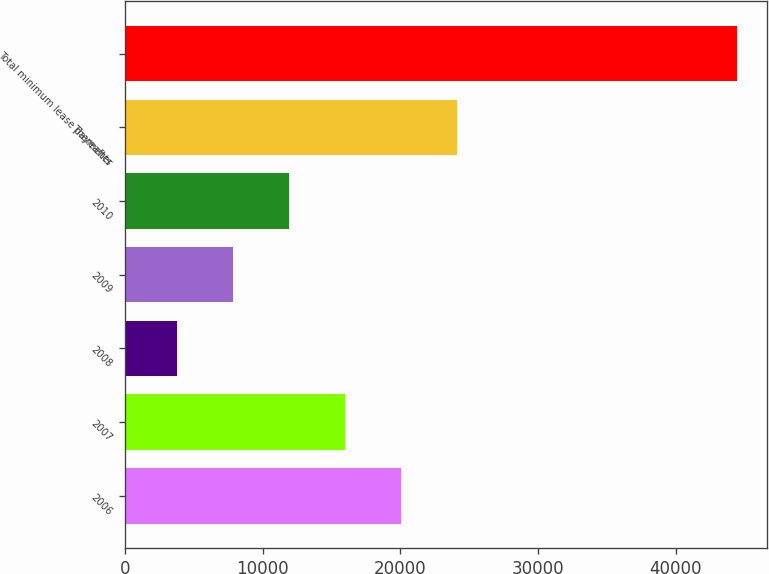Convert chart to OTSL. <chart><loc_0><loc_0><loc_500><loc_500><bar_chart><fcel>2006<fcel>2007<fcel>2008<fcel>2009<fcel>2010<fcel>Thereafter<fcel>Total minimum lease payments<nl><fcel>20027.6<fcel>15959.2<fcel>3754<fcel>7822.4<fcel>11890.8<fcel>24096<fcel>44438<nl></chart> 